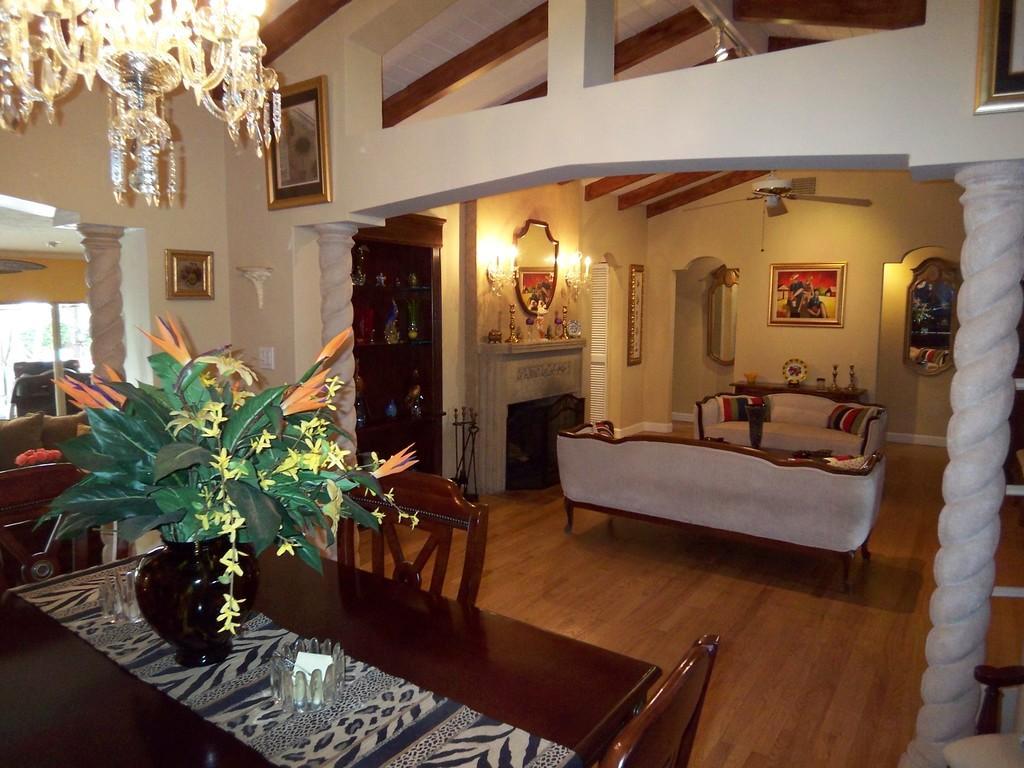Can you describe this image briefly? This image is clicked inside the house. It looks like the living room. Where, there are sofas in the middle of the image. To the right, there is a small pillar of arch. To the left, there is a dining table on which a plant is kept. In the background there is wall, fireplace, photo frame on the wall, and mirror. 